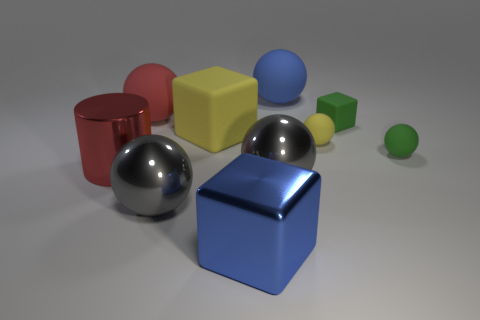Subtract all matte cubes. How many cubes are left? 1 Add 6 red balls. How many red balls exist? 7 Subtract all blue cubes. How many cubes are left? 2 Subtract 1 red balls. How many objects are left? 9 Subtract all cylinders. How many objects are left? 9 Subtract 1 cylinders. How many cylinders are left? 0 Subtract all green cylinders. Subtract all yellow balls. How many cylinders are left? 1 Subtract all cyan spheres. How many brown cylinders are left? 0 Subtract all red matte objects. Subtract all tiny green balls. How many objects are left? 8 Add 5 large blue metallic cubes. How many large blue metallic cubes are left? 6 